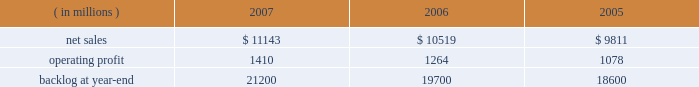Air mobility sales declined by $ 535 million primarily due to c-130j deliveries ( 12 in 2006 compared to 15 in 2005 ) and lower volume on the c-5 program .
Combat aircraft sales increased by $ 292 million mainly due to higher f-35 and f-22 volume , partially offset by reduced volume on f-16 programs .
Other aeronautics programs sales increased by $ 83 million primarily due to higher volume in sustainment services activities .
Operating profit for the segment increased 21% ( 21 % ) in 2007 compared to 2006 .
Operating profit increases in combat aircraft more than offset decreases in other aeronautics programs and air mobility .
Combat aircraft operating profit increased $ 326 million mainly due to improved performance on f-22 and f-16 programs .
Air mobility and other aeronautics programs declined $ 77 million due to lower operating profit in support and sustainment activities .
Operating profit for the segment increased 20% ( 20 % ) in 2006 compared to 2005 .
Operating profit increased in both combat aircraft and air mobility .
Combat aircraft increased $ 114 million , mainly due to higher volume on the f-35 and f-22 programs , and improved performance on f-16 programs .
The improvement for the year was also attributable in part to the fact that in 2005 , operating profit included a reduction in earnings on the f-35 program .
Air mobility operating profit increased $ 84 million , mainly due to improved performance on c-130j sustainment activities in 2006 .
Backlog decreased in 2007 as compared to 2006 primarily as a result of sales volume on the f-35 program .
This decrease was offset partially by increased orders on the f-22 and c-130j programs .
Electronic systems electronic systems 2019 operating results included the following : ( in millions ) 2007 2006 2005 .
Net sales for electronic systems increased by 6% ( 6 % ) in 2007 compared to 2006 .
Sales increased in missiles & fire control ( m&fc ) , maritime systems & sensors ( ms2 ) , and platform , training & energy ( pt&e ) .
M&fc sales increased $ 258 million mainly due to higher volume in fire control systems and air defense programs , which more than offset declines in tactical missile programs .
Ms2 sales grew $ 254 million due to volume increases in undersea and radar systems activities that were offset partially by decreases in surface systems activities .
Pt&e sales increased $ 113 million , primarily due to higher volume in platform integration activities , which more than offset declines in distribution technology activities .
Net sales for electronic systems increased by 7% ( 7 % ) in 2006 compared to 2005 .
Higher volume in platform integration activities led to increased sales of $ 329 million at pt&e .
Ms2 sales increased $ 267 million primarily due to surface systems activities .
Air defense programs contributed to increased sales of $ 118 million at m&fc .
Operating profit for the segment increased by 12% ( 12 % ) in 2007 compared to 2006 , representing an increase in all three lines of business during the year .
Operating profit increased $ 70 million at pt&e primarily due to higher volume and improved performance on platform integration activities .
Ms2 operating profit increased $ 32 million due to higher volume on undersea and tactical systems activities that more than offset lower volume on surface systems activities .
At m&fc , operating profit increased $ 32 million due to higher volume in fire control systems and improved performance in tactical missile programs , which partially were offset by performance on certain international air defense programs in 2006 .
Operating profit for the segment increased by 17% ( 17 % ) in 2006 compared to 2005 .
Operating profit increased by $ 74 million at ms2 mainly due to higher volume on surface systems and undersea programs .
Pt&e operating profit increased $ 61 million mainly due to improved performance on distribution technology activities .
Higher volume on air defense programs contributed to a $ 52 million increase in operating profit at m&fc .
The increase in backlog during 2007 over 2006 resulted primarily from increased orders for certain tactical missile programs and fire control systems at m&fc and platform integration programs at pt&e. .
What was the percentage change in backlog from 2005 to 2006? 
Computations: ((19700 - 18600) / 18600)
Answer: 0.05914. 